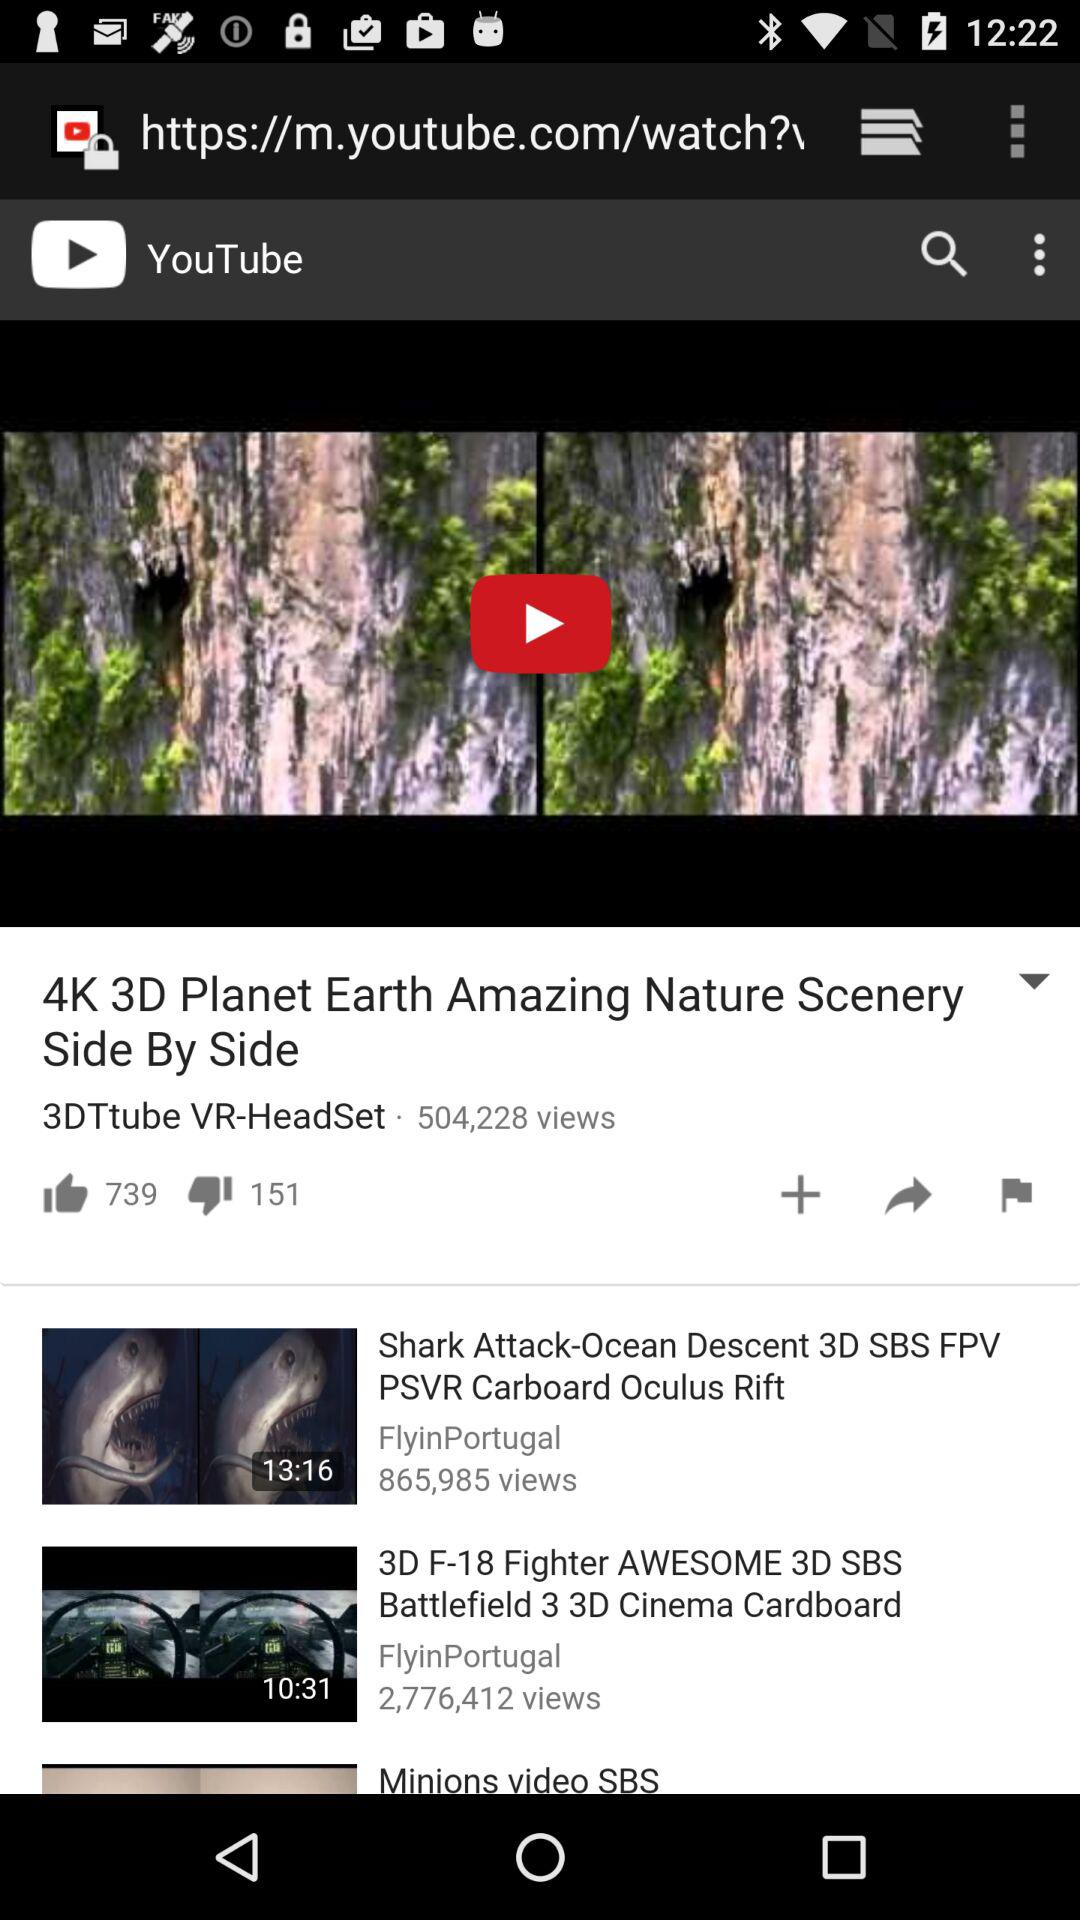How many people watched the "3D F-18 Fighter AWESOME" video? There are 2,776,412 people who watched the "3D F-18 Fighter AWESOME" video. 